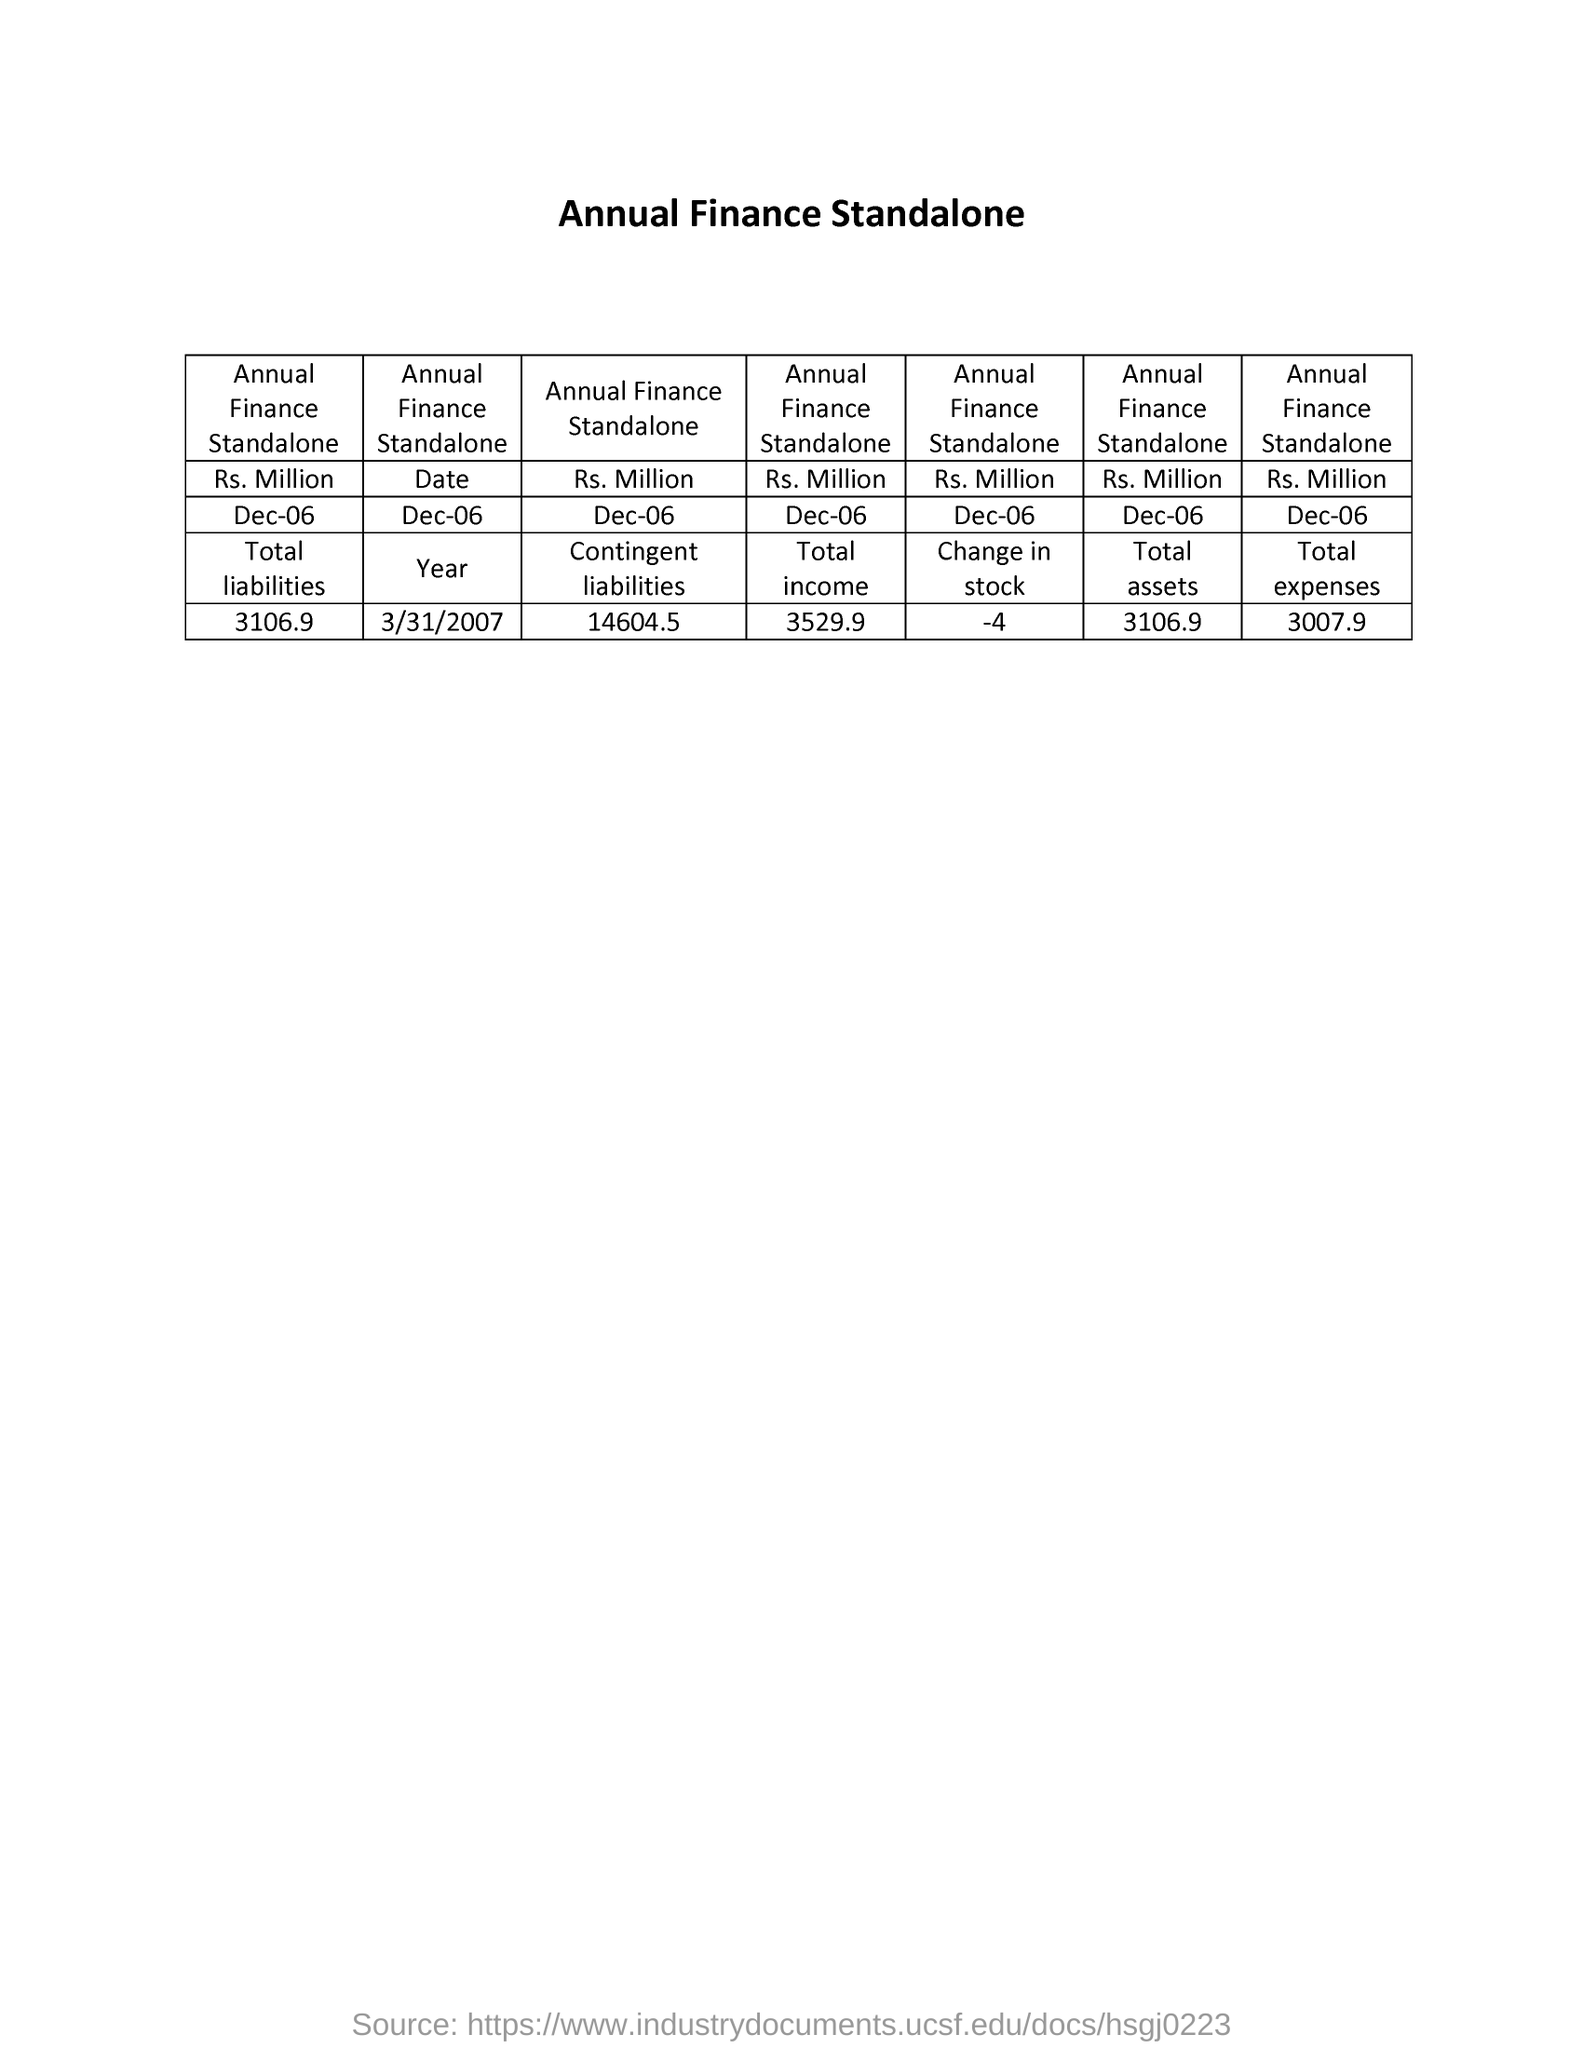Identify some key points in this picture. The annual finance standalone report for the change in stock as of December 6, 2022, is -4 million US dollars. As of December 6, the annual finance standalone revenue for total income was $3,529.9 million. The total assets of the annual finance stand alone as of December 6th were 3,106.9 million dollars. The total expenses for the annual finance department stood at $300.79 million as on December 6, 2020. As of December 6th, the annual finance stand-alone RS millions for contingent liabilities is 14,604.5. 